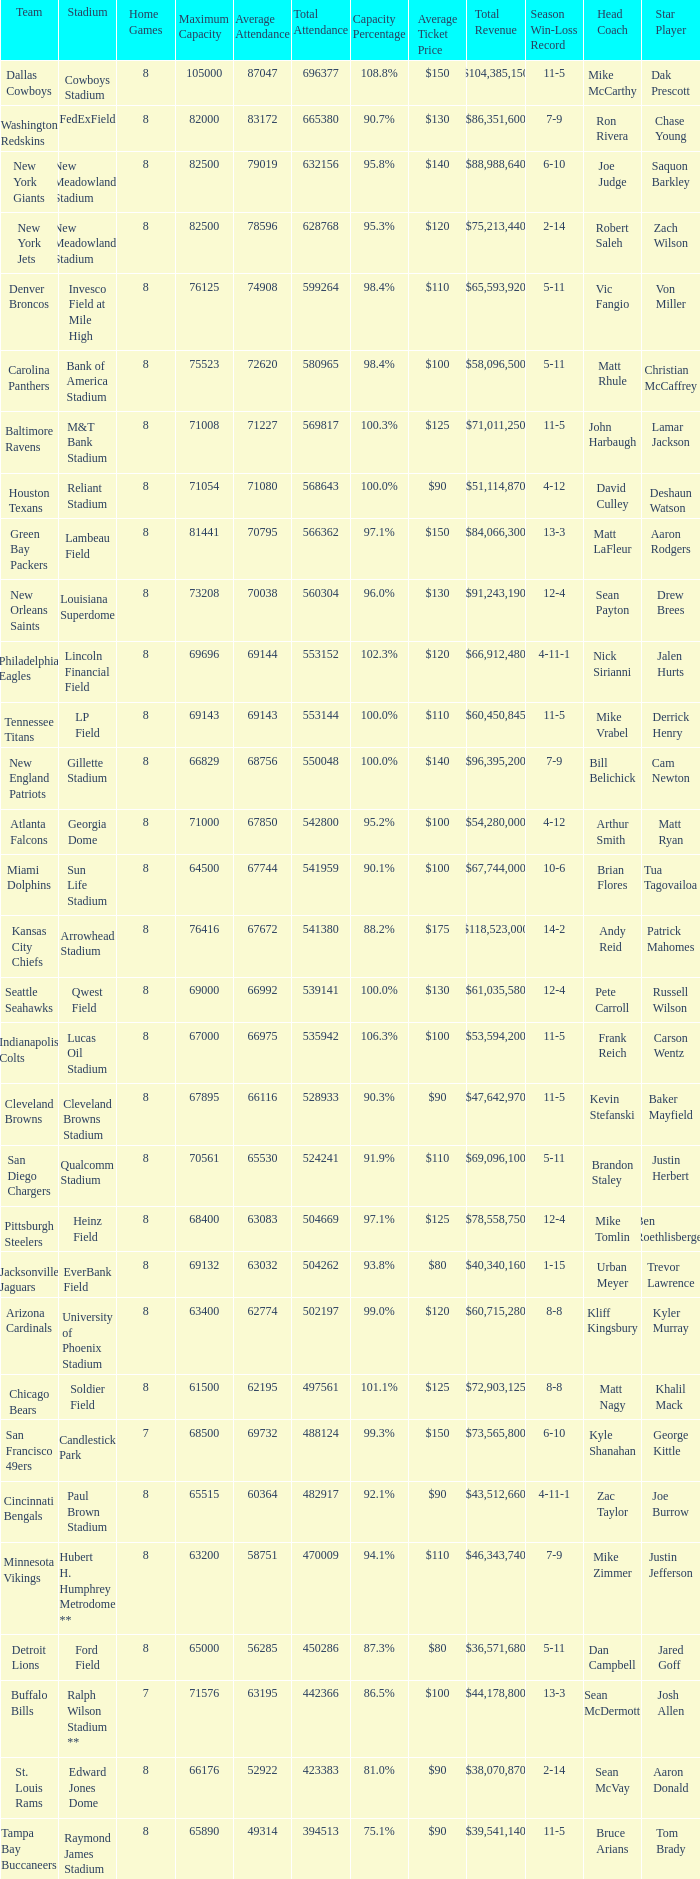What was average attendance when total attendance was 541380? 67672.0. 